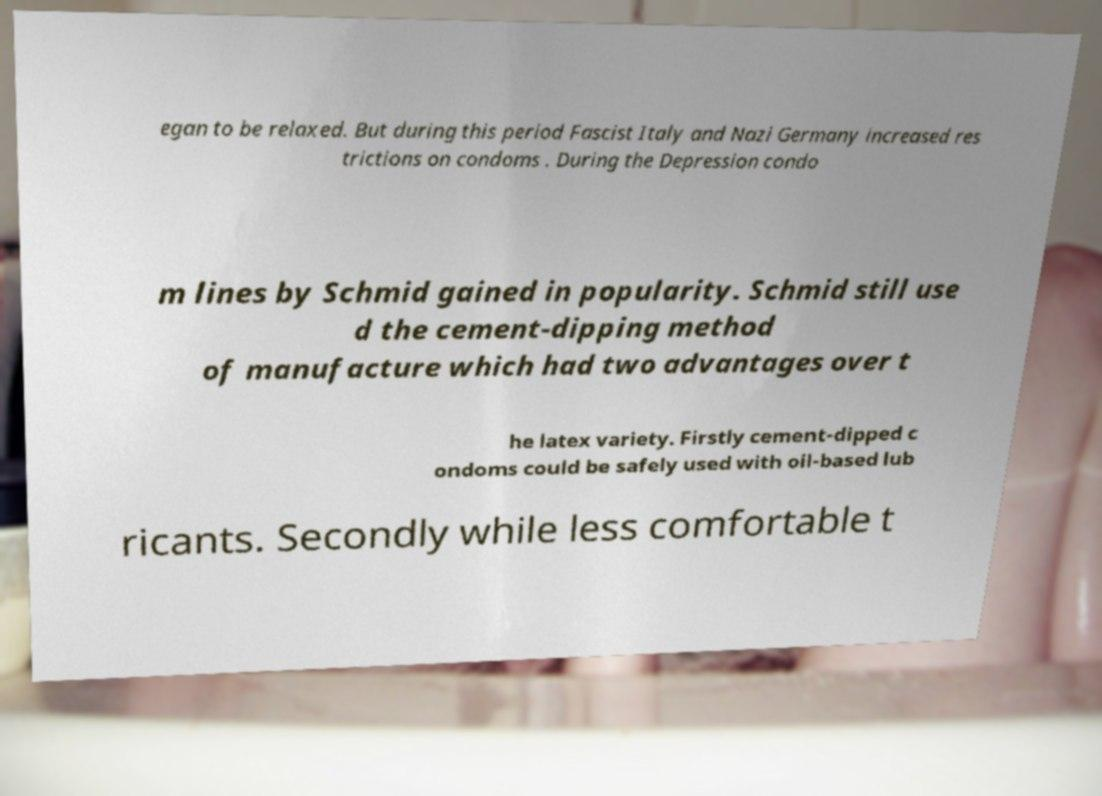For documentation purposes, I need the text within this image transcribed. Could you provide that? egan to be relaxed. But during this period Fascist Italy and Nazi Germany increased res trictions on condoms . During the Depression condo m lines by Schmid gained in popularity. Schmid still use d the cement-dipping method of manufacture which had two advantages over t he latex variety. Firstly cement-dipped c ondoms could be safely used with oil-based lub ricants. Secondly while less comfortable t 